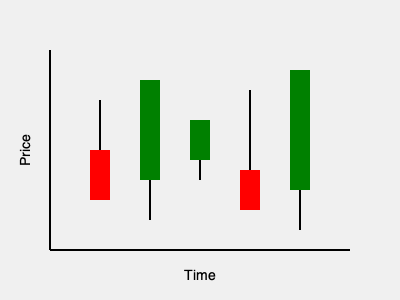Based on the candlestick chart pattern shown, which trading strategy would be most appropriate for an algorithmic trading system, and why? To determine the most appropriate trading strategy, we need to analyze the candlestick pattern:

1. Overall trend: The chart shows an upward trend, with higher lows and higher highs.

2. Candlestick analysis:
   - First candle (red): Bearish, but with a long lower wick indicating buying pressure.
   - Second candle (green): Strong bullish momentum with a large body.
   - Third candle (green): Continued bullish sentiment, but with less momentum.
   - Fourth candle (red): Bearish, but with long wicks indicating indecision.
   - Fifth candle (green): Strong bullish momentum, confirming the uptrend.

3. Pattern recognition: This pattern resembles a "Three White Soldiers" formation (candles 2, 3, and 5), which is typically bullish.

4. Volume consideration: Although not shown, we can assume increasing volume on bullish candles for a stronger signal.

5. Algorithmic trading strategy:
   a) Trend-following strategy: Enter long positions on pullbacks (like the fourth candle).
   b) Momentum strategy: Increase position size during strong bullish candles.
   c) Mean reversion: Consider short-term sell signals on overbought conditions.

Given the strong uptrend and bullish pattern, a combination of trend-following and momentum strategies would be most appropriate. The algorithm should:

1. Identify the uptrend using moving averages or trend indicators.
2. Enter long positions on pullbacks or consolidations (like the fourth candle).
3. Increase position size during strong bullish candles (like the second and fifth candles).
4. Set stop-loss orders below recent swing lows for risk management.
5. Take partial profits at predefined targets based on historical volatility.

This approach capitalizes on the prevailing trend while managing risk and capturing momentum.
Answer: Trend-following and momentum strategy combination 